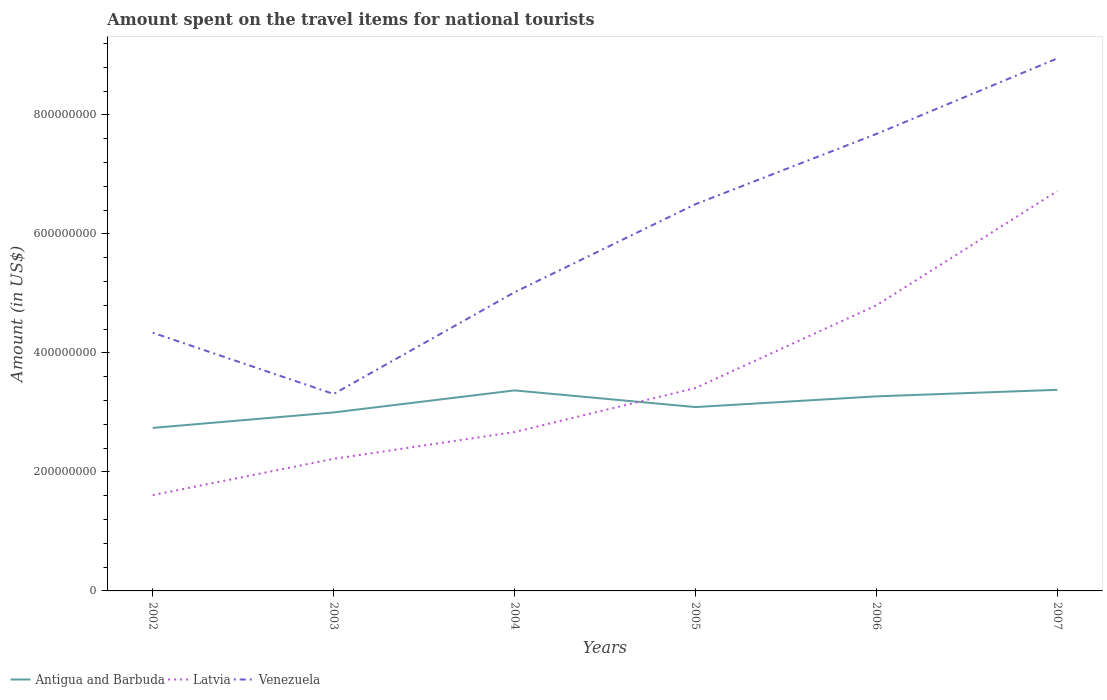How many different coloured lines are there?
Offer a very short reply. 3. Across all years, what is the maximum amount spent on the travel items for national tourists in Venezuela?
Your answer should be very brief. 3.31e+08. In which year was the amount spent on the travel items for national tourists in Latvia maximum?
Your answer should be compact. 2002. What is the total amount spent on the travel items for national tourists in Venezuela in the graph?
Your response must be concise. -2.45e+08. What is the difference between the highest and the second highest amount spent on the travel items for national tourists in Venezuela?
Ensure brevity in your answer.  5.64e+08. What is the difference between two consecutive major ticks on the Y-axis?
Make the answer very short. 2.00e+08. Are the values on the major ticks of Y-axis written in scientific E-notation?
Your response must be concise. No. Where does the legend appear in the graph?
Your response must be concise. Bottom left. How many legend labels are there?
Your response must be concise. 3. What is the title of the graph?
Make the answer very short. Amount spent on the travel items for national tourists. What is the label or title of the Y-axis?
Ensure brevity in your answer.  Amount (in US$). What is the Amount (in US$) of Antigua and Barbuda in 2002?
Offer a terse response. 2.74e+08. What is the Amount (in US$) in Latvia in 2002?
Your answer should be compact. 1.61e+08. What is the Amount (in US$) in Venezuela in 2002?
Offer a very short reply. 4.34e+08. What is the Amount (in US$) in Antigua and Barbuda in 2003?
Provide a short and direct response. 3.00e+08. What is the Amount (in US$) in Latvia in 2003?
Keep it short and to the point. 2.22e+08. What is the Amount (in US$) of Venezuela in 2003?
Your answer should be compact. 3.31e+08. What is the Amount (in US$) in Antigua and Barbuda in 2004?
Provide a short and direct response. 3.37e+08. What is the Amount (in US$) of Latvia in 2004?
Your answer should be compact. 2.67e+08. What is the Amount (in US$) in Venezuela in 2004?
Provide a short and direct response. 5.02e+08. What is the Amount (in US$) of Antigua and Barbuda in 2005?
Offer a terse response. 3.09e+08. What is the Amount (in US$) in Latvia in 2005?
Your answer should be compact. 3.41e+08. What is the Amount (in US$) in Venezuela in 2005?
Your answer should be very brief. 6.50e+08. What is the Amount (in US$) of Antigua and Barbuda in 2006?
Keep it short and to the point. 3.27e+08. What is the Amount (in US$) in Latvia in 2006?
Provide a succinct answer. 4.80e+08. What is the Amount (in US$) of Venezuela in 2006?
Keep it short and to the point. 7.68e+08. What is the Amount (in US$) of Antigua and Barbuda in 2007?
Give a very brief answer. 3.38e+08. What is the Amount (in US$) in Latvia in 2007?
Your answer should be very brief. 6.72e+08. What is the Amount (in US$) in Venezuela in 2007?
Make the answer very short. 8.95e+08. Across all years, what is the maximum Amount (in US$) in Antigua and Barbuda?
Make the answer very short. 3.38e+08. Across all years, what is the maximum Amount (in US$) of Latvia?
Your response must be concise. 6.72e+08. Across all years, what is the maximum Amount (in US$) in Venezuela?
Give a very brief answer. 8.95e+08. Across all years, what is the minimum Amount (in US$) in Antigua and Barbuda?
Give a very brief answer. 2.74e+08. Across all years, what is the minimum Amount (in US$) of Latvia?
Your answer should be compact. 1.61e+08. Across all years, what is the minimum Amount (in US$) in Venezuela?
Provide a succinct answer. 3.31e+08. What is the total Amount (in US$) of Antigua and Barbuda in the graph?
Ensure brevity in your answer.  1.88e+09. What is the total Amount (in US$) in Latvia in the graph?
Offer a very short reply. 2.14e+09. What is the total Amount (in US$) in Venezuela in the graph?
Provide a succinct answer. 3.58e+09. What is the difference between the Amount (in US$) of Antigua and Barbuda in 2002 and that in 2003?
Make the answer very short. -2.60e+07. What is the difference between the Amount (in US$) of Latvia in 2002 and that in 2003?
Your answer should be very brief. -6.10e+07. What is the difference between the Amount (in US$) in Venezuela in 2002 and that in 2003?
Your response must be concise. 1.03e+08. What is the difference between the Amount (in US$) in Antigua and Barbuda in 2002 and that in 2004?
Ensure brevity in your answer.  -6.30e+07. What is the difference between the Amount (in US$) in Latvia in 2002 and that in 2004?
Provide a succinct answer. -1.06e+08. What is the difference between the Amount (in US$) in Venezuela in 2002 and that in 2004?
Offer a terse response. -6.80e+07. What is the difference between the Amount (in US$) in Antigua and Barbuda in 2002 and that in 2005?
Provide a short and direct response. -3.50e+07. What is the difference between the Amount (in US$) in Latvia in 2002 and that in 2005?
Ensure brevity in your answer.  -1.80e+08. What is the difference between the Amount (in US$) in Venezuela in 2002 and that in 2005?
Make the answer very short. -2.16e+08. What is the difference between the Amount (in US$) of Antigua and Barbuda in 2002 and that in 2006?
Make the answer very short. -5.30e+07. What is the difference between the Amount (in US$) of Latvia in 2002 and that in 2006?
Keep it short and to the point. -3.19e+08. What is the difference between the Amount (in US$) of Venezuela in 2002 and that in 2006?
Keep it short and to the point. -3.34e+08. What is the difference between the Amount (in US$) in Antigua and Barbuda in 2002 and that in 2007?
Give a very brief answer. -6.40e+07. What is the difference between the Amount (in US$) in Latvia in 2002 and that in 2007?
Offer a very short reply. -5.11e+08. What is the difference between the Amount (in US$) in Venezuela in 2002 and that in 2007?
Offer a terse response. -4.61e+08. What is the difference between the Amount (in US$) of Antigua and Barbuda in 2003 and that in 2004?
Give a very brief answer. -3.70e+07. What is the difference between the Amount (in US$) in Latvia in 2003 and that in 2004?
Offer a terse response. -4.50e+07. What is the difference between the Amount (in US$) of Venezuela in 2003 and that in 2004?
Offer a terse response. -1.71e+08. What is the difference between the Amount (in US$) in Antigua and Barbuda in 2003 and that in 2005?
Ensure brevity in your answer.  -9.00e+06. What is the difference between the Amount (in US$) in Latvia in 2003 and that in 2005?
Ensure brevity in your answer.  -1.19e+08. What is the difference between the Amount (in US$) in Venezuela in 2003 and that in 2005?
Make the answer very short. -3.19e+08. What is the difference between the Amount (in US$) in Antigua and Barbuda in 2003 and that in 2006?
Provide a short and direct response. -2.70e+07. What is the difference between the Amount (in US$) of Latvia in 2003 and that in 2006?
Make the answer very short. -2.58e+08. What is the difference between the Amount (in US$) in Venezuela in 2003 and that in 2006?
Offer a very short reply. -4.37e+08. What is the difference between the Amount (in US$) in Antigua and Barbuda in 2003 and that in 2007?
Provide a short and direct response. -3.80e+07. What is the difference between the Amount (in US$) of Latvia in 2003 and that in 2007?
Provide a short and direct response. -4.50e+08. What is the difference between the Amount (in US$) in Venezuela in 2003 and that in 2007?
Your response must be concise. -5.64e+08. What is the difference between the Amount (in US$) in Antigua and Barbuda in 2004 and that in 2005?
Ensure brevity in your answer.  2.80e+07. What is the difference between the Amount (in US$) in Latvia in 2004 and that in 2005?
Your answer should be compact. -7.40e+07. What is the difference between the Amount (in US$) in Venezuela in 2004 and that in 2005?
Provide a succinct answer. -1.48e+08. What is the difference between the Amount (in US$) in Antigua and Barbuda in 2004 and that in 2006?
Keep it short and to the point. 1.00e+07. What is the difference between the Amount (in US$) of Latvia in 2004 and that in 2006?
Provide a succinct answer. -2.13e+08. What is the difference between the Amount (in US$) of Venezuela in 2004 and that in 2006?
Offer a very short reply. -2.66e+08. What is the difference between the Amount (in US$) of Latvia in 2004 and that in 2007?
Offer a very short reply. -4.05e+08. What is the difference between the Amount (in US$) of Venezuela in 2004 and that in 2007?
Make the answer very short. -3.93e+08. What is the difference between the Amount (in US$) of Antigua and Barbuda in 2005 and that in 2006?
Make the answer very short. -1.80e+07. What is the difference between the Amount (in US$) in Latvia in 2005 and that in 2006?
Keep it short and to the point. -1.39e+08. What is the difference between the Amount (in US$) in Venezuela in 2005 and that in 2006?
Your answer should be very brief. -1.18e+08. What is the difference between the Amount (in US$) of Antigua and Barbuda in 2005 and that in 2007?
Ensure brevity in your answer.  -2.90e+07. What is the difference between the Amount (in US$) of Latvia in 2005 and that in 2007?
Give a very brief answer. -3.31e+08. What is the difference between the Amount (in US$) of Venezuela in 2005 and that in 2007?
Give a very brief answer. -2.45e+08. What is the difference between the Amount (in US$) of Antigua and Barbuda in 2006 and that in 2007?
Your answer should be very brief. -1.10e+07. What is the difference between the Amount (in US$) of Latvia in 2006 and that in 2007?
Keep it short and to the point. -1.92e+08. What is the difference between the Amount (in US$) of Venezuela in 2006 and that in 2007?
Your answer should be very brief. -1.27e+08. What is the difference between the Amount (in US$) of Antigua and Barbuda in 2002 and the Amount (in US$) of Latvia in 2003?
Your answer should be compact. 5.20e+07. What is the difference between the Amount (in US$) of Antigua and Barbuda in 2002 and the Amount (in US$) of Venezuela in 2003?
Your answer should be very brief. -5.70e+07. What is the difference between the Amount (in US$) in Latvia in 2002 and the Amount (in US$) in Venezuela in 2003?
Provide a short and direct response. -1.70e+08. What is the difference between the Amount (in US$) in Antigua and Barbuda in 2002 and the Amount (in US$) in Latvia in 2004?
Your answer should be compact. 7.00e+06. What is the difference between the Amount (in US$) in Antigua and Barbuda in 2002 and the Amount (in US$) in Venezuela in 2004?
Make the answer very short. -2.28e+08. What is the difference between the Amount (in US$) in Latvia in 2002 and the Amount (in US$) in Venezuela in 2004?
Make the answer very short. -3.41e+08. What is the difference between the Amount (in US$) of Antigua and Barbuda in 2002 and the Amount (in US$) of Latvia in 2005?
Make the answer very short. -6.70e+07. What is the difference between the Amount (in US$) of Antigua and Barbuda in 2002 and the Amount (in US$) of Venezuela in 2005?
Your answer should be very brief. -3.76e+08. What is the difference between the Amount (in US$) in Latvia in 2002 and the Amount (in US$) in Venezuela in 2005?
Keep it short and to the point. -4.89e+08. What is the difference between the Amount (in US$) of Antigua and Barbuda in 2002 and the Amount (in US$) of Latvia in 2006?
Your answer should be very brief. -2.06e+08. What is the difference between the Amount (in US$) in Antigua and Barbuda in 2002 and the Amount (in US$) in Venezuela in 2006?
Make the answer very short. -4.94e+08. What is the difference between the Amount (in US$) in Latvia in 2002 and the Amount (in US$) in Venezuela in 2006?
Give a very brief answer. -6.07e+08. What is the difference between the Amount (in US$) of Antigua and Barbuda in 2002 and the Amount (in US$) of Latvia in 2007?
Keep it short and to the point. -3.98e+08. What is the difference between the Amount (in US$) in Antigua and Barbuda in 2002 and the Amount (in US$) in Venezuela in 2007?
Offer a very short reply. -6.21e+08. What is the difference between the Amount (in US$) of Latvia in 2002 and the Amount (in US$) of Venezuela in 2007?
Give a very brief answer. -7.34e+08. What is the difference between the Amount (in US$) in Antigua and Barbuda in 2003 and the Amount (in US$) in Latvia in 2004?
Offer a terse response. 3.30e+07. What is the difference between the Amount (in US$) of Antigua and Barbuda in 2003 and the Amount (in US$) of Venezuela in 2004?
Offer a terse response. -2.02e+08. What is the difference between the Amount (in US$) of Latvia in 2003 and the Amount (in US$) of Venezuela in 2004?
Give a very brief answer. -2.80e+08. What is the difference between the Amount (in US$) of Antigua and Barbuda in 2003 and the Amount (in US$) of Latvia in 2005?
Your answer should be compact. -4.10e+07. What is the difference between the Amount (in US$) of Antigua and Barbuda in 2003 and the Amount (in US$) of Venezuela in 2005?
Give a very brief answer. -3.50e+08. What is the difference between the Amount (in US$) of Latvia in 2003 and the Amount (in US$) of Venezuela in 2005?
Your answer should be very brief. -4.28e+08. What is the difference between the Amount (in US$) of Antigua and Barbuda in 2003 and the Amount (in US$) of Latvia in 2006?
Your answer should be very brief. -1.80e+08. What is the difference between the Amount (in US$) in Antigua and Barbuda in 2003 and the Amount (in US$) in Venezuela in 2006?
Provide a short and direct response. -4.68e+08. What is the difference between the Amount (in US$) in Latvia in 2003 and the Amount (in US$) in Venezuela in 2006?
Your answer should be very brief. -5.46e+08. What is the difference between the Amount (in US$) in Antigua and Barbuda in 2003 and the Amount (in US$) in Latvia in 2007?
Provide a succinct answer. -3.72e+08. What is the difference between the Amount (in US$) of Antigua and Barbuda in 2003 and the Amount (in US$) of Venezuela in 2007?
Provide a short and direct response. -5.95e+08. What is the difference between the Amount (in US$) of Latvia in 2003 and the Amount (in US$) of Venezuela in 2007?
Provide a succinct answer. -6.73e+08. What is the difference between the Amount (in US$) of Antigua and Barbuda in 2004 and the Amount (in US$) of Venezuela in 2005?
Keep it short and to the point. -3.13e+08. What is the difference between the Amount (in US$) in Latvia in 2004 and the Amount (in US$) in Venezuela in 2005?
Provide a succinct answer. -3.83e+08. What is the difference between the Amount (in US$) in Antigua and Barbuda in 2004 and the Amount (in US$) in Latvia in 2006?
Your answer should be very brief. -1.43e+08. What is the difference between the Amount (in US$) of Antigua and Barbuda in 2004 and the Amount (in US$) of Venezuela in 2006?
Keep it short and to the point. -4.31e+08. What is the difference between the Amount (in US$) of Latvia in 2004 and the Amount (in US$) of Venezuela in 2006?
Keep it short and to the point. -5.01e+08. What is the difference between the Amount (in US$) of Antigua and Barbuda in 2004 and the Amount (in US$) of Latvia in 2007?
Offer a very short reply. -3.35e+08. What is the difference between the Amount (in US$) in Antigua and Barbuda in 2004 and the Amount (in US$) in Venezuela in 2007?
Give a very brief answer. -5.58e+08. What is the difference between the Amount (in US$) in Latvia in 2004 and the Amount (in US$) in Venezuela in 2007?
Give a very brief answer. -6.28e+08. What is the difference between the Amount (in US$) in Antigua and Barbuda in 2005 and the Amount (in US$) in Latvia in 2006?
Your answer should be very brief. -1.71e+08. What is the difference between the Amount (in US$) in Antigua and Barbuda in 2005 and the Amount (in US$) in Venezuela in 2006?
Provide a short and direct response. -4.59e+08. What is the difference between the Amount (in US$) in Latvia in 2005 and the Amount (in US$) in Venezuela in 2006?
Your response must be concise. -4.27e+08. What is the difference between the Amount (in US$) of Antigua and Barbuda in 2005 and the Amount (in US$) of Latvia in 2007?
Make the answer very short. -3.63e+08. What is the difference between the Amount (in US$) of Antigua and Barbuda in 2005 and the Amount (in US$) of Venezuela in 2007?
Make the answer very short. -5.86e+08. What is the difference between the Amount (in US$) in Latvia in 2005 and the Amount (in US$) in Venezuela in 2007?
Ensure brevity in your answer.  -5.54e+08. What is the difference between the Amount (in US$) of Antigua and Barbuda in 2006 and the Amount (in US$) of Latvia in 2007?
Offer a very short reply. -3.45e+08. What is the difference between the Amount (in US$) in Antigua and Barbuda in 2006 and the Amount (in US$) in Venezuela in 2007?
Make the answer very short. -5.68e+08. What is the difference between the Amount (in US$) of Latvia in 2006 and the Amount (in US$) of Venezuela in 2007?
Give a very brief answer. -4.15e+08. What is the average Amount (in US$) of Antigua and Barbuda per year?
Offer a terse response. 3.14e+08. What is the average Amount (in US$) of Latvia per year?
Provide a succinct answer. 3.57e+08. What is the average Amount (in US$) in Venezuela per year?
Make the answer very short. 5.97e+08. In the year 2002, what is the difference between the Amount (in US$) in Antigua and Barbuda and Amount (in US$) in Latvia?
Provide a short and direct response. 1.13e+08. In the year 2002, what is the difference between the Amount (in US$) in Antigua and Barbuda and Amount (in US$) in Venezuela?
Offer a very short reply. -1.60e+08. In the year 2002, what is the difference between the Amount (in US$) of Latvia and Amount (in US$) of Venezuela?
Provide a succinct answer. -2.73e+08. In the year 2003, what is the difference between the Amount (in US$) in Antigua and Barbuda and Amount (in US$) in Latvia?
Offer a terse response. 7.80e+07. In the year 2003, what is the difference between the Amount (in US$) of Antigua and Barbuda and Amount (in US$) of Venezuela?
Your response must be concise. -3.10e+07. In the year 2003, what is the difference between the Amount (in US$) of Latvia and Amount (in US$) of Venezuela?
Provide a short and direct response. -1.09e+08. In the year 2004, what is the difference between the Amount (in US$) of Antigua and Barbuda and Amount (in US$) of Latvia?
Make the answer very short. 7.00e+07. In the year 2004, what is the difference between the Amount (in US$) in Antigua and Barbuda and Amount (in US$) in Venezuela?
Provide a short and direct response. -1.65e+08. In the year 2004, what is the difference between the Amount (in US$) in Latvia and Amount (in US$) in Venezuela?
Keep it short and to the point. -2.35e+08. In the year 2005, what is the difference between the Amount (in US$) in Antigua and Barbuda and Amount (in US$) in Latvia?
Offer a very short reply. -3.20e+07. In the year 2005, what is the difference between the Amount (in US$) of Antigua and Barbuda and Amount (in US$) of Venezuela?
Provide a succinct answer. -3.41e+08. In the year 2005, what is the difference between the Amount (in US$) in Latvia and Amount (in US$) in Venezuela?
Keep it short and to the point. -3.09e+08. In the year 2006, what is the difference between the Amount (in US$) in Antigua and Barbuda and Amount (in US$) in Latvia?
Your answer should be very brief. -1.53e+08. In the year 2006, what is the difference between the Amount (in US$) of Antigua and Barbuda and Amount (in US$) of Venezuela?
Provide a succinct answer. -4.41e+08. In the year 2006, what is the difference between the Amount (in US$) in Latvia and Amount (in US$) in Venezuela?
Give a very brief answer. -2.88e+08. In the year 2007, what is the difference between the Amount (in US$) of Antigua and Barbuda and Amount (in US$) of Latvia?
Provide a succinct answer. -3.34e+08. In the year 2007, what is the difference between the Amount (in US$) in Antigua and Barbuda and Amount (in US$) in Venezuela?
Make the answer very short. -5.57e+08. In the year 2007, what is the difference between the Amount (in US$) of Latvia and Amount (in US$) of Venezuela?
Your answer should be very brief. -2.23e+08. What is the ratio of the Amount (in US$) of Antigua and Barbuda in 2002 to that in 2003?
Provide a succinct answer. 0.91. What is the ratio of the Amount (in US$) of Latvia in 2002 to that in 2003?
Make the answer very short. 0.73. What is the ratio of the Amount (in US$) of Venezuela in 2002 to that in 2003?
Provide a short and direct response. 1.31. What is the ratio of the Amount (in US$) of Antigua and Barbuda in 2002 to that in 2004?
Give a very brief answer. 0.81. What is the ratio of the Amount (in US$) in Latvia in 2002 to that in 2004?
Keep it short and to the point. 0.6. What is the ratio of the Amount (in US$) in Venezuela in 2002 to that in 2004?
Make the answer very short. 0.86. What is the ratio of the Amount (in US$) in Antigua and Barbuda in 2002 to that in 2005?
Your answer should be very brief. 0.89. What is the ratio of the Amount (in US$) of Latvia in 2002 to that in 2005?
Your answer should be compact. 0.47. What is the ratio of the Amount (in US$) in Venezuela in 2002 to that in 2005?
Keep it short and to the point. 0.67. What is the ratio of the Amount (in US$) of Antigua and Barbuda in 2002 to that in 2006?
Offer a very short reply. 0.84. What is the ratio of the Amount (in US$) in Latvia in 2002 to that in 2006?
Give a very brief answer. 0.34. What is the ratio of the Amount (in US$) of Venezuela in 2002 to that in 2006?
Ensure brevity in your answer.  0.57. What is the ratio of the Amount (in US$) of Antigua and Barbuda in 2002 to that in 2007?
Provide a succinct answer. 0.81. What is the ratio of the Amount (in US$) of Latvia in 2002 to that in 2007?
Offer a very short reply. 0.24. What is the ratio of the Amount (in US$) of Venezuela in 2002 to that in 2007?
Make the answer very short. 0.48. What is the ratio of the Amount (in US$) in Antigua and Barbuda in 2003 to that in 2004?
Make the answer very short. 0.89. What is the ratio of the Amount (in US$) of Latvia in 2003 to that in 2004?
Give a very brief answer. 0.83. What is the ratio of the Amount (in US$) in Venezuela in 2003 to that in 2004?
Offer a terse response. 0.66. What is the ratio of the Amount (in US$) of Antigua and Barbuda in 2003 to that in 2005?
Offer a very short reply. 0.97. What is the ratio of the Amount (in US$) of Latvia in 2003 to that in 2005?
Your response must be concise. 0.65. What is the ratio of the Amount (in US$) of Venezuela in 2003 to that in 2005?
Provide a short and direct response. 0.51. What is the ratio of the Amount (in US$) in Antigua and Barbuda in 2003 to that in 2006?
Offer a terse response. 0.92. What is the ratio of the Amount (in US$) of Latvia in 2003 to that in 2006?
Offer a terse response. 0.46. What is the ratio of the Amount (in US$) of Venezuela in 2003 to that in 2006?
Your answer should be very brief. 0.43. What is the ratio of the Amount (in US$) in Antigua and Barbuda in 2003 to that in 2007?
Ensure brevity in your answer.  0.89. What is the ratio of the Amount (in US$) of Latvia in 2003 to that in 2007?
Offer a very short reply. 0.33. What is the ratio of the Amount (in US$) in Venezuela in 2003 to that in 2007?
Provide a succinct answer. 0.37. What is the ratio of the Amount (in US$) of Antigua and Barbuda in 2004 to that in 2005?
Make the answer very short. 1.09. What is the ratio of the Amount (in US$) of Latvia in 2004 to that in 2005?
Offer a very short reply. 0.78. What is the ratio of the Amount (in US$) of Venezuela in 2004 to that in 2005?
Your answer should be very brief. 0.77. What is the ratio of the Amount (in US$) in Antigua and Barbuda in 2004 to that in 2006?
Ensure brevity in your answer.  1.03. What is the ratio of the Amount (in US$) of Latvia in 2004 to that in 2006?
Your answer should be compact. 0.56. What is the ratio of the Amount (in US$) in Venezuela in 2004 to that in 2006?
Offer a very short reply. 0.65. What is the ratio of the Amount (in US$) of Latvia in 2004 to that in 2007?
Keep it short and to the point. 0.4. What is the ratio of the Amount (in US$) in Venezuela in 2004 to that in 2007?
Provide a short and direct response. 0.56. What is the ratio of the Amount (in US$) of Antigua and Barbuda in 2005 to that in 2006?
Offer a terse response. 0.94. What is the ratio of the Amount (in US$) in Latvia in 2005 to that in 2006?
Give a very brief answer. 0.71. What is the ratio of the Amount (in US$) in Venezuela in 2005 to that in 2006?
Provide a short and direct response. 0.85. What is the ratio of the Amount (in US$) of Antigua and Barbuda in 2005 to that in 2007?
Give a very brief answer. 0.91. What is the ratio of the Amount (in US$) in Latvia in 2005 to that in 2007?
Provide a succinct answer. 0.51. What is the ratio of the Amount (in US$) in Venezuela in 2005 to that in 2007?
Offer a very short reply. 0.73. What is the ratio of the Amount (in US$) in Antigua and Barbuda in 2006 to that in 2007?
Offer a very short reply. 0.97. What is the ratio of the Amount (in US$) of Venezuela in 2006 to that in 2007?
Offer a very short reply. 0.86. What is the difference between the highest and the second highest Amount (in US$) of Antigua and Barbuda?
Your answer should be compact. 1.00e+06. What is the difference between the highest and the second highest Amount (in US$) of Latvia?
Provide a short and direct response. 1.92e+08. What is the difference between the highest and the second highest Amount (in US$) of Venezuela?
Make the answer very short. 1.27e+08. What is the difference between the highest and the lowest Amount (in US$) of Antigua and Barbuda?
Keep it short and to the point. 6.40e+07. What is the difference between the highest and the lowest Amount (in US$) of Latvia?
Your answer should be very brief. 5.11e+08. What is the difference between the highest and the lowest Amount (in US$) of Venezuela?
Give a very brief answer. 5.64e+08. 